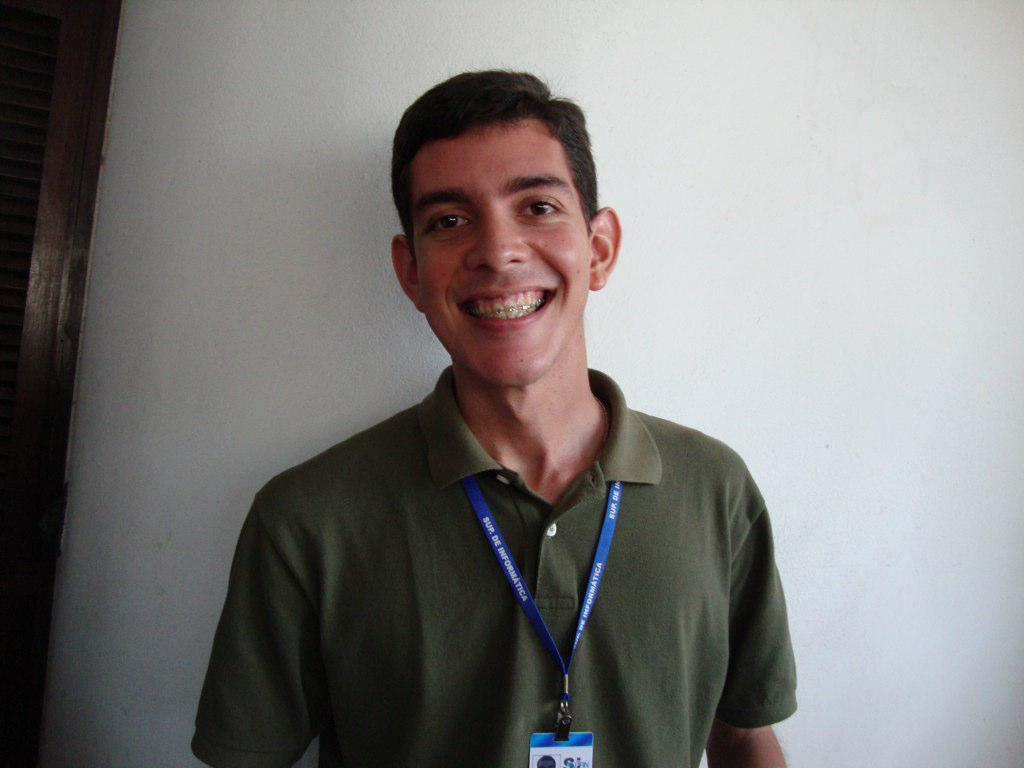What is the main subject in the image? There is a person in the image. What type of army is depicted in the image? There is no army present in the image; it only features a person. Can you tell me how the person is flying in the image? The person is not flying in the image; they are standing or sitting, as there is no indication of flight. 